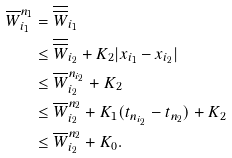Convert formula to latex. <formula><loc_0><loc_0><loc_500><loc_500>\overline { W } _ { i _ { 1 } } ^ { n _ { 1 } } & = \overline { \overline { W } } _ { i _ { 1 } } \\ & \leq \overline { \overline { W } } _ { i _ { 2 } } + K _ { 2 } | x _ { i _ { 1 } } - x _ { i _ { 2 } } | \\ & \leq \overline { W } _ { i _ { 2 } } ^ { n _ { i _ { 2 } } } + K _ { 2 } \\ & \leq \overline { W } _ { i _ { 2 } } ^ { n _ { 2 } } + K _ { 1 } ( t _ { n _ { i _ { 2 } } } - t _ { n _ { 2 } } ) + K _ { 2 } \\ & \leq \overline { W } _ { i _ { 2 } } ^ { n _ { 2 } } + K _ { 0 } .</formula> 